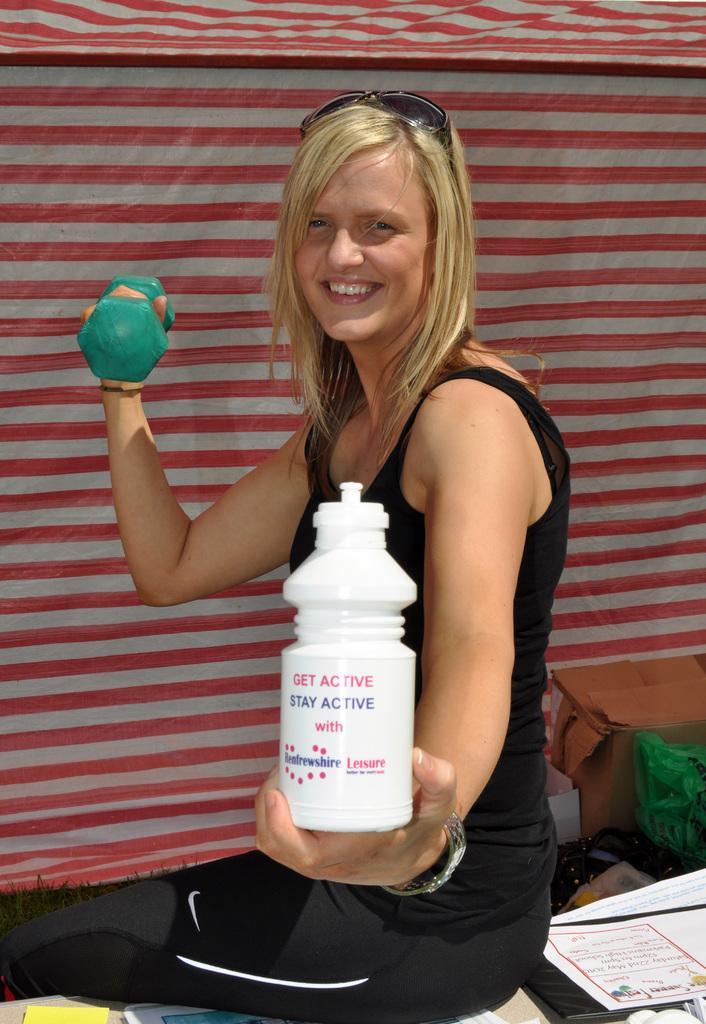Can you describe this image briefly? In this picture, In the middle there is a woman she is sitting and she is holding a bottle in her left hand which is in white color she is holding a dumbbell in her right rand which is in blue color, In the background there is a red and white color curtain. 